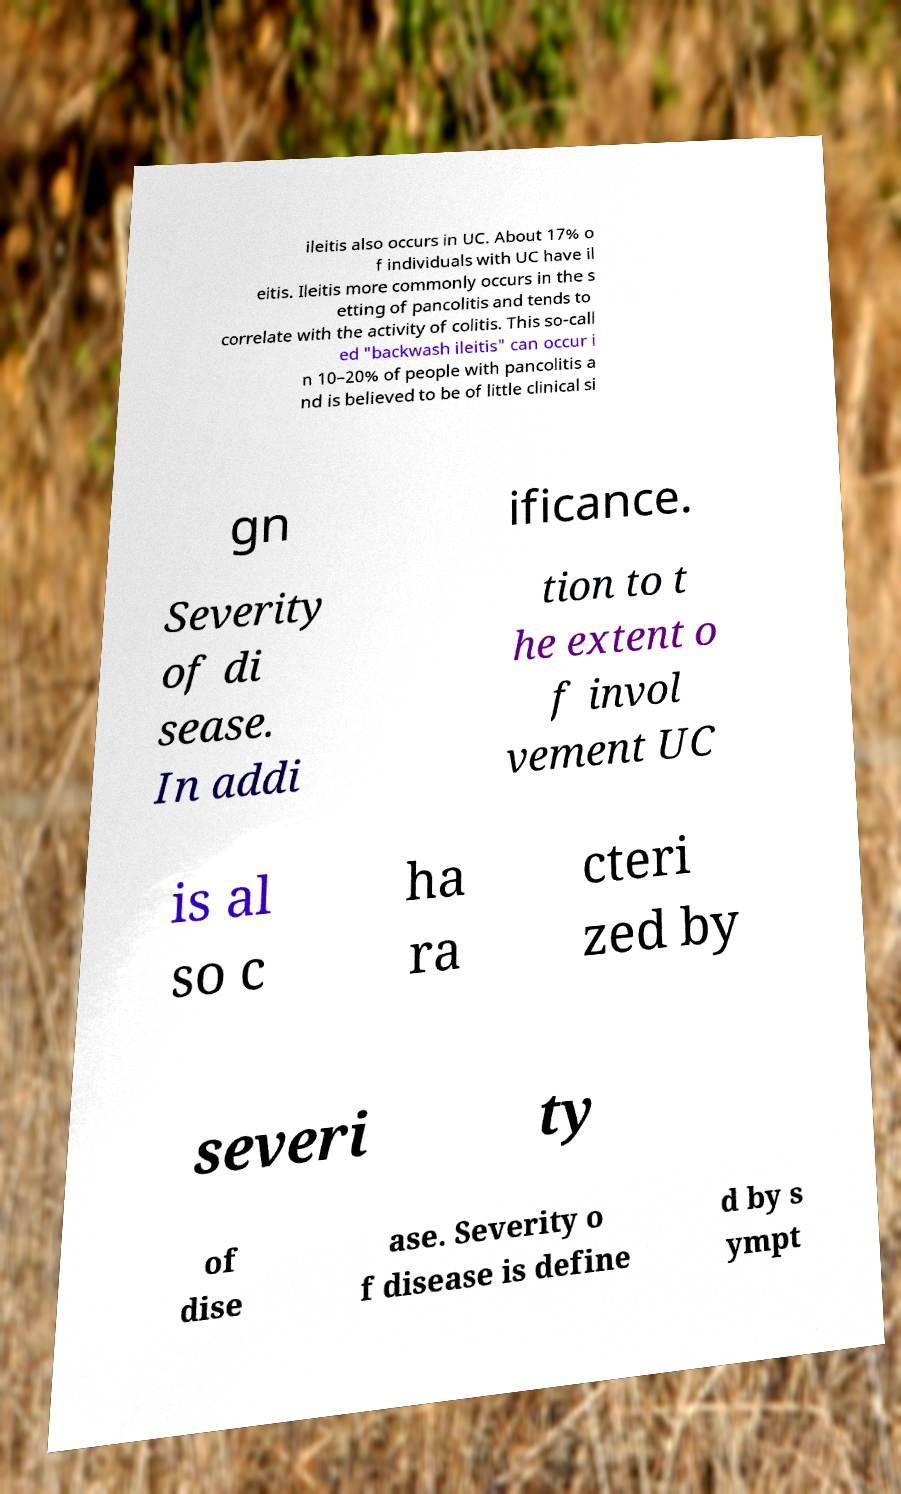Could you assist in decoding the text presented in this image and type it out clearly? ileitis also occurs in UC. About 17% o f individuals with UC have il eitis. Ileitis more commonly occurs in the s etting of pancolitis and tends to correlate with the activity of colitis. This so-call ed "backwash ileitis" can occur i n 10–20% of people with pancolitis a nd is believed to be of little clinical si gn ificance. Severity of di sease. In addi tion to t he extent o f invol vement UC is al so c ha ra cteri zed by severi ty of dise ase. Severity o f disease is define d by s ympt 